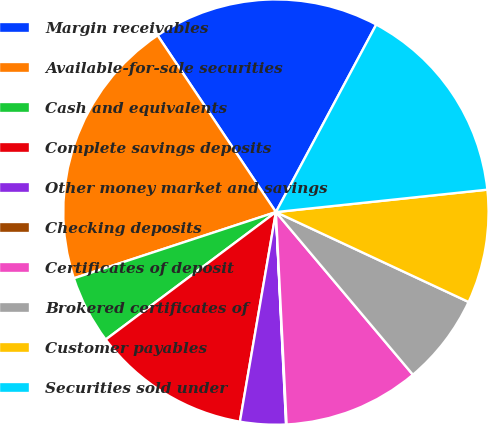Convert chart. <chart><loc_0><loc_0><loc_500><loc_500><pie_chart><fcel>Margin receivables<fcel>Available-for-sale securities<fcel>Cash and equivalents<fcel>Complete savings deposits<fcel>Other money market and savings<fcel>Checking deposits<fcel>Certificates of deposit<fcel>Brokered certificates of<fcel>Customer payables<fcel>Securities sold under<nl><fcel>17.21%<fcel>20.65%<fcel>5.19%<fcel>12.06%<fcel>3.47%<fcel>0.04%<fcel>10.34%<fcel>6.91%<fcel>8.63%<fcel>15.5%<nl></chart> 